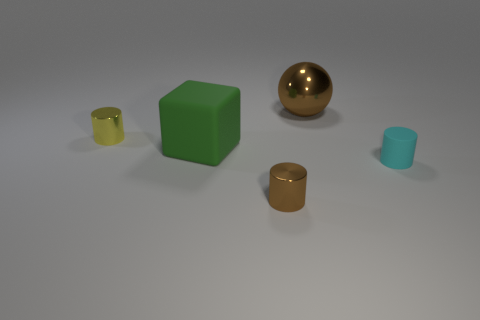Is there a cylinder of the same color as the metallic ball?
Keep it short and to the point. Yes. Is the number of cyan cylinders that are in front of the small yellow shiny cylinder greater than the number of cyan objects behind the green matte cube?
Make the answer very short. Yes. The rubber thing on the left side of the shiny cylinder that is right of the big green rubber cube that is in front of the metal ball is what color?
Your response must be concise. Green. There is a cylinder to the left of the big rubber object; is it the same color as the tiny rubber thing?
Provide a short and direct response. No. What number of other objects are the same color as the big block?
Keep it short and to the point. 0. How many things are metallic things or small gray shiny things?
Ensure brevity in your answer.  3. How many things are big purple metal things or big green things that are in front of the ball?
Your answer should be very brief. 1. Is the green thing made of the same material as the big brown ball?
Ensure brevity in your answer.  No. How many other objects are the same material as the brown sphere?
Provide a succinct answer. 2. Are there more brown metallic things than tiny blue things?
Give a very brief answer. Yes. 